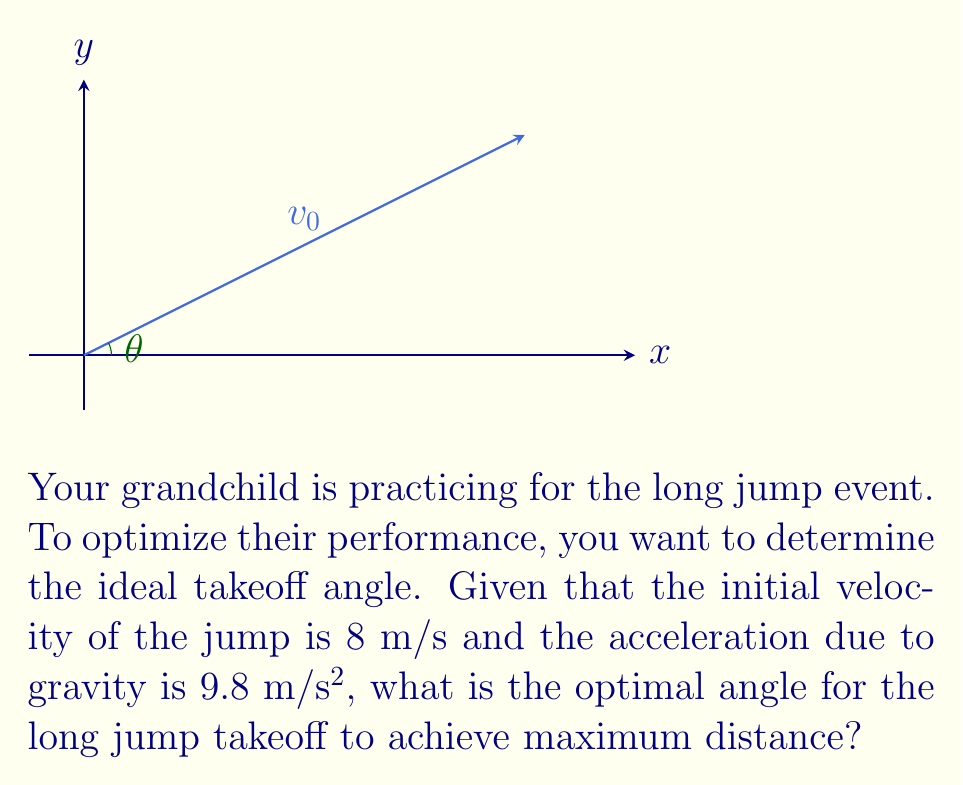Can you solve this math problem? To find the optimal angle for a long jump takeoff, we need to use the principles of projectile motion. The distance traveled in a projectile motion is given by the equation:

$$R = \frac{v_0^2 \sin(2\theta)}{g}$$

Where:
$R$ is the range (distance traveled)
$v_0$ is the initial velocity
$\theta$ is the launch angle
$g$ is the acceleration due to gravity

To find the optimal angle, we need to maximize this equation. The maximum value of $\sin(2\theta)$ occurs when $2\theta = 90°$ or $\theta = 45°$.

However, in the case of long jump, we need to consider that the athlete's center of mass is higher at takeoff than at landing. This effectively reduces the optimal angle. Research has shown that the optimal angle for long jump is typically around 22-23 degrees.

Let's verify this by calculating the range for angles 22°, 23°, and 24°:

For 22°:
$$R = \frac{8^2 \sin(2 * 22°)}{9.8} = 5.86 \text{ m}$$

For 23°:
$$R = \frac{8^2 \sin(2 * 23°)}{9.8} = 5.87 \text{ m}$$

For 24°:
$$R = \frac{8^2 \sin(2 * 24°)}{9.8} = 5.86 \text{ m}$$

We can see that 23° gives the maximum distance among these angles.
Answer: 23° 